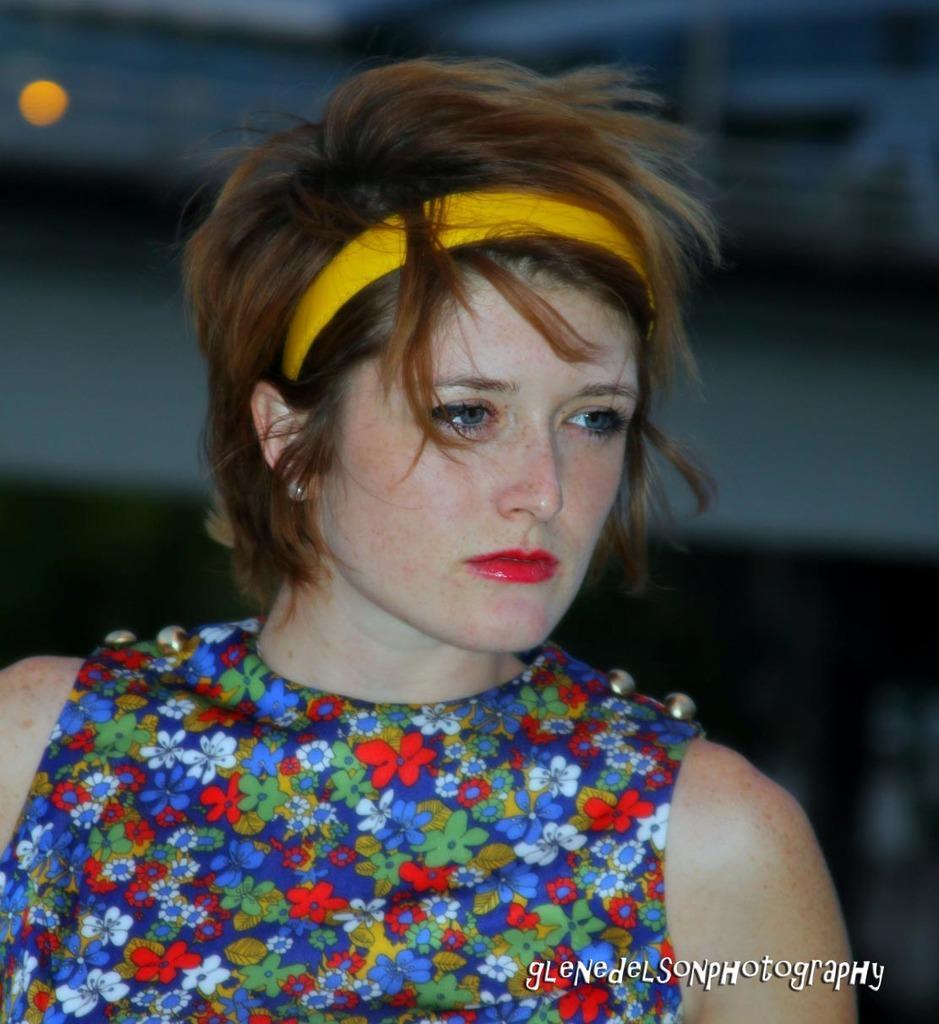Describe this image in one or two sentences. In this image, I can see the woman with a colorful dress and a hair band. The background looks blurry. This is the watermark on the image. 